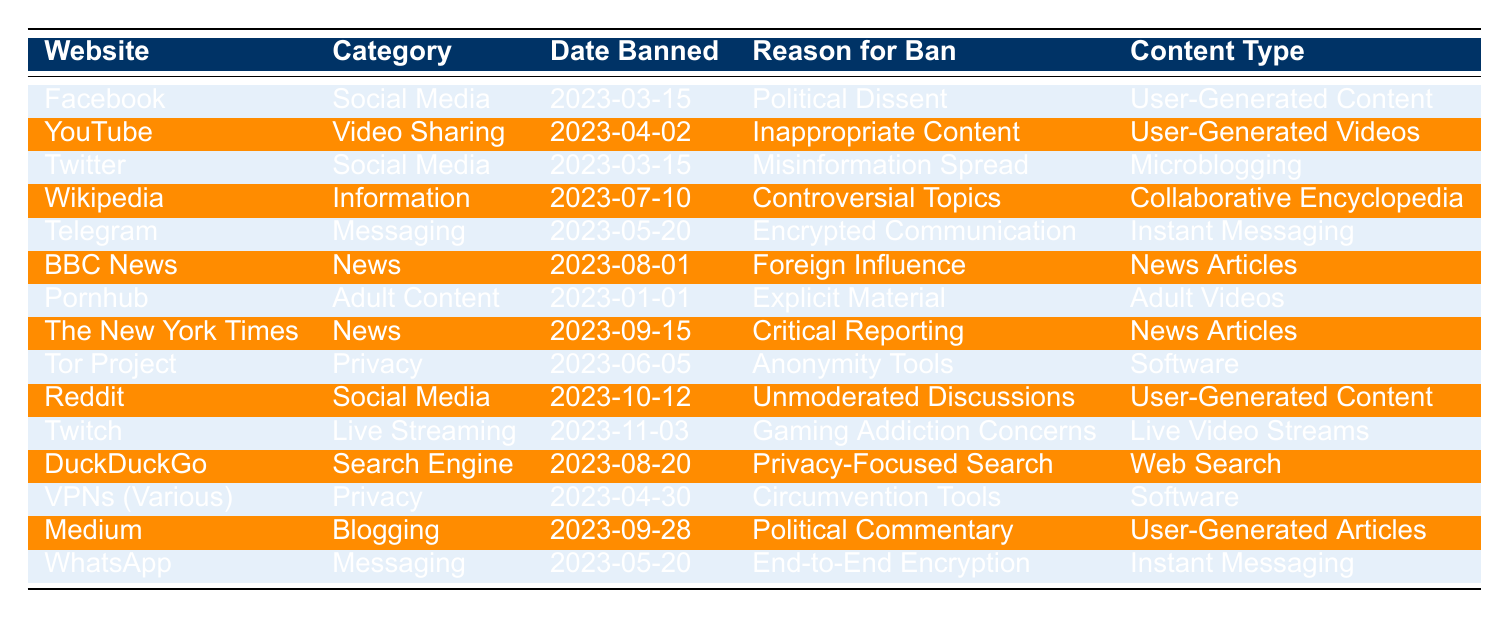What is the date when Facebook was banned? The table lists the "Date Banned" column for each website. For Facebook, the "Date Banned" is recorded as "2023-03-15."
Answer: 2023-03-15 How many websites were banned in the "Social Media" category? The table indicates that three websites fall under the "Social Media" category: Facebook, Twitter, and Reddit. Therefore, the total is 3.
Answer: 3 Which website was banned due to "Foreign Influence"? By looking under the "Reason for Ban" column, "BBC News" is associated with the reason "Foreign Influence."
Answer: BBC News What is the latest website that was banned? The "Date Banned" column shows the most recent date is "2023-11-03" for the website "Twitch."
Answer: Twitch Was "Wikipedia" banned for a reason related to news reporting? The table shows that "Wikipedia" was banned for "Controversial Topics" which does not relate specifically to news reporting.
Answer: No Which category has the most banned websites? If we count the occurrences in each category, "Social Media" and "News" both have three entries each. Thus, both categories tie for the highest count.
Answer: Social Media and News What content type does "Pornhub" have? Looking under the "Content Type" column for "Pornhub," it is classified as "Adult Videos."
Answer: Adult Videos Are there more banned websites in the "Messaging" category or the "Privacy" category? The "Messaging" category has two entries (Telegram and WhatsApp), while the "Privacy" category has two entries (Tor Project and VPNs). Both categories have equal counts.
Answer: Equal What are the reasons behind the banning of the websites in the "News" category? From the table, "BBC News" was banned for "Foreign Influence" and "The New York Times" for "Critical Reporting," hence both are based on how news is perceived.
Answer: Foreign Influence and Critical Reporting How many websites were banned in the first quarter of the year? In the "Date Banned" column, we see that "Pornhub," "Facebook," and "Twitter" were all banned before April. This gives a total of 3 websites in the first quarter.
Answer: 3 